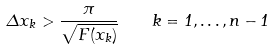Convert formula to latex. <formula><loc_0><loc_0><loc_500><loc_500>\Delta x _ { k } > \frac { \pi } { \sqrt { F ( x _ { k } ) } } \quad k = 1 , \dots , n - 1</formula> 